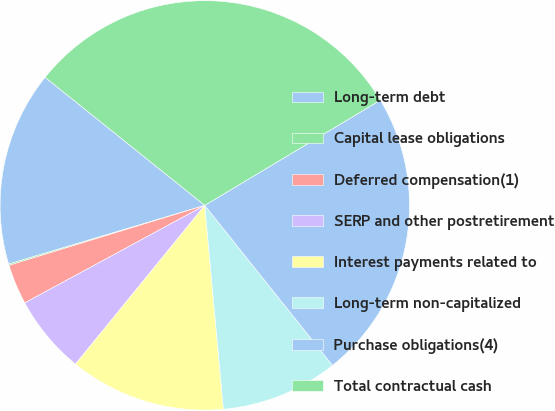Convert chart to OTSL. <chart><loc_0><loc_0><loc_500><loc_500><pie_chart><fcel>Long-term debt<fcel>Capital lease obligations<fcel>Deferred compensation(1)<fcel>SERP and other postretirement<fcel>Interest payments related to<fcel>Long-term non-capitalized<fcel>Purchase obligations(4)<fcel>Total contractual cash<nl><fcel>15.38%<fcel>0.11%<fcel>3.17%<fcel>6.22%<fcel>12.33%<fcel>9.27%<fcel>22.87%<fcel>30.65%<nl></chart> 